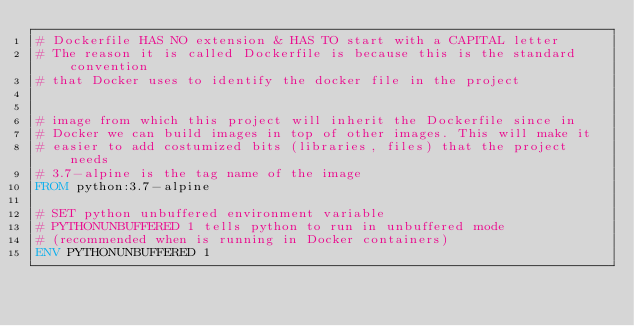Convert code to text. <code><loc_0><loc_0><loc_500><loc_500><_Dockerfile_># Dockerfile HAS NO extension & HAS TO start with a CAPITAL letter
# The reason it is called Dockerfile is because this is the standard convention
# that Docker uses to identify the docker file in the project


# image from which this project will inherit the Dockerfile since in 
# Docker we can build images in top of other images. This will make it 
# easier to add costumized bits (libraries, files) that the project needs
# 3.7-alpine is the tag name of the image
FROM python:3.7-alpine  

# SET python unbuffered environment variable
# PYTHONUNBUFFERED 1 tells python to run in unbuffered mode 
# (recommended when is running in Docker containers)
ENV PYTHONUNBUFFERED 1
</code> 